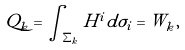Convert formula to latex. <formula><loc_0><loc_0><loc_500><loc_500>Q _ { k } = \int _ { \Sigma _ { k } } H ^ { i } d \sigma _ { i } = W _ { k } ,</formula> 